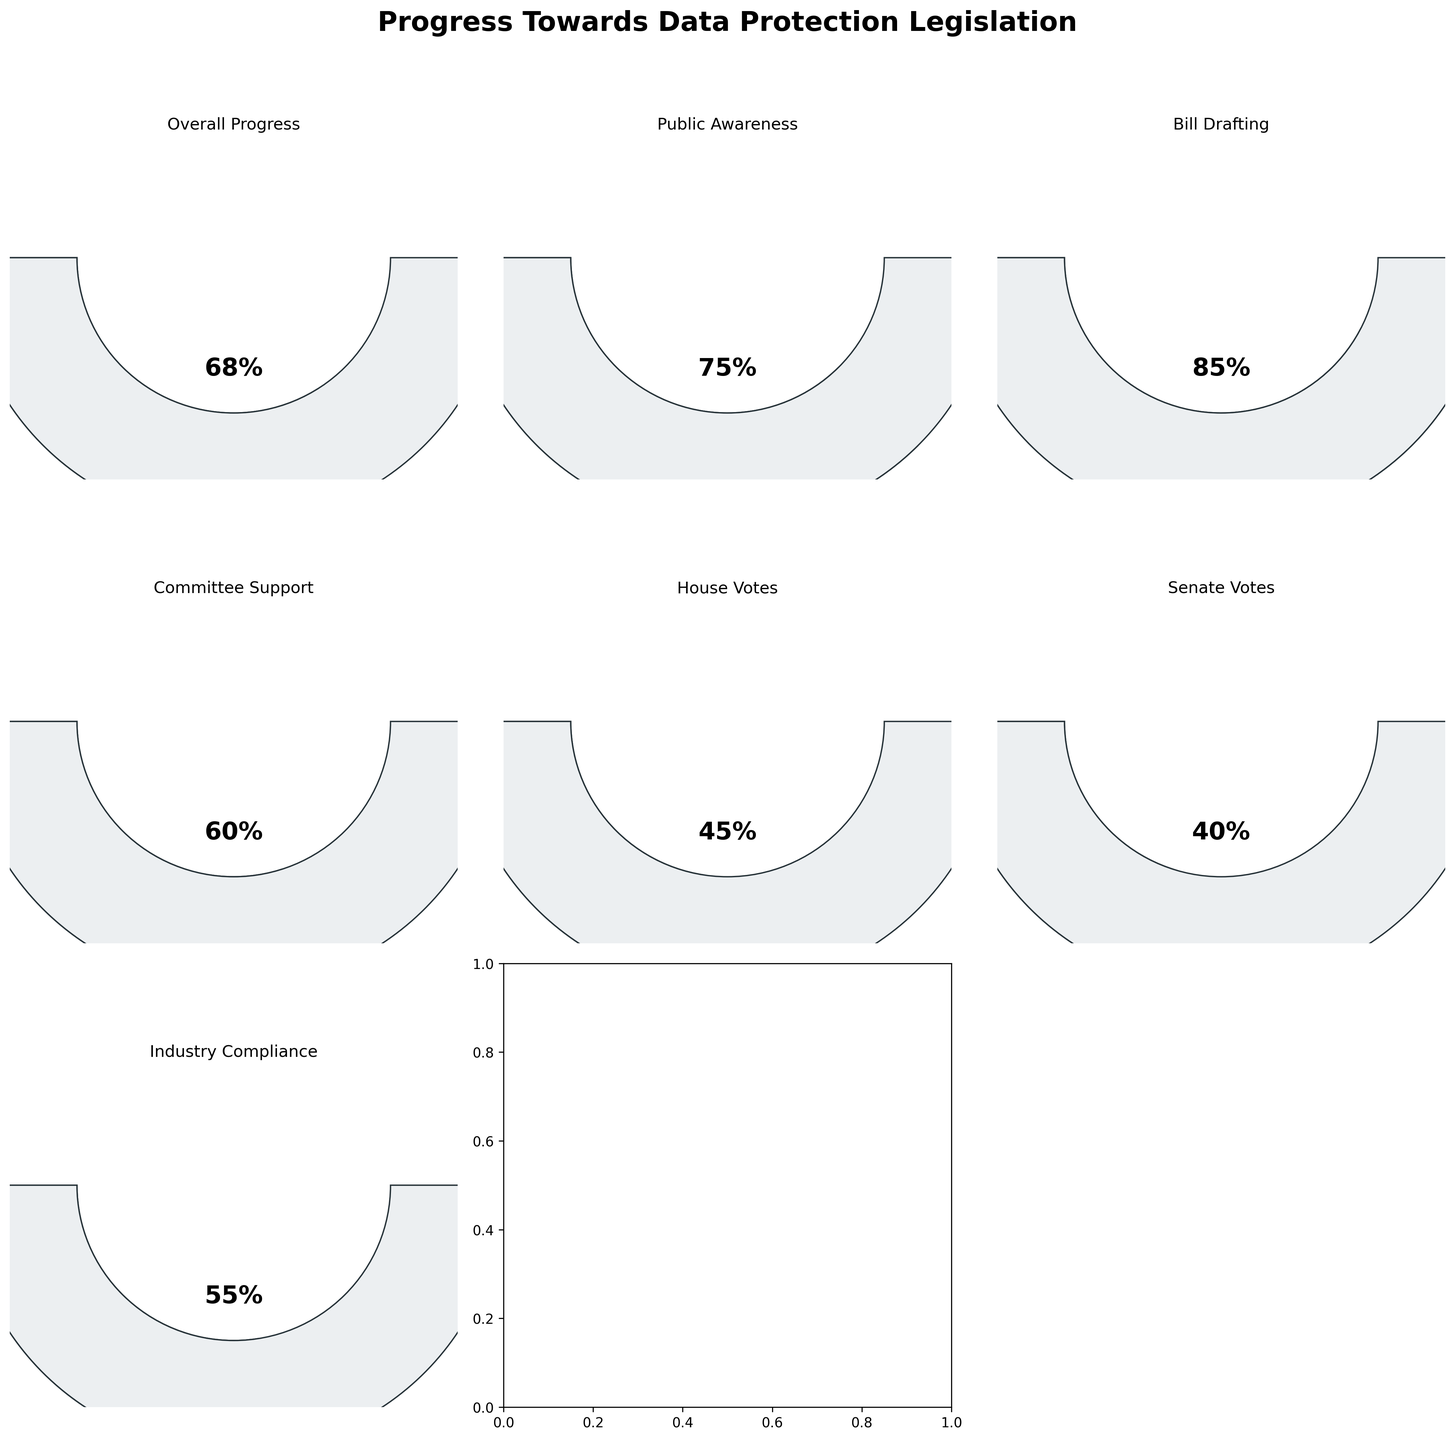What is the overall progress percentage towards the data protection legislation? The overall progress towards the data protection legislation is represented by the "Overall Progress" gauge, which shows 68%.
Answer: 68% Which category has the highest progress percentage? By looking at the different gauges, the "Bill Drafting" category has the highest progress percentage at 85%.
Answer: Bill Drafting How does the progress of public awareness compare to industry compliance? Public awareness has a progress of 75%, whereas industry compliance has a progress of 55%. Therefore, public awareness has made more progress.
Answer: Public awareness has made more progress Which two categories have the lowest progress percentages? The "House Votes" and "Senate Votes" categories have the lowest progress percentages, with 45% and 40% respectively.
Answer: House Votes and Senate Votes What is the average progress percentage across all categories? Add up all the progress percentages (68 + 75 + 85 + 60 + 45 + 40 + 55) to get 428, and then divide by the number of categories (7). The average progress is 428 / 7 ≈ 61.14%.
Answer: 61.14% What is the difference in progress between committee support and senate votes? Committee support has 60% progress, and senate votes have 40% progress. The difference is 60% - 40% = 20%.
Answer: 20% Does any category have exactly half the progress of bill drafting? Bill drafting has 85% progress. Half of 85% is 42.5%. No other category has exactly 42.5%, but the closest is senate votes with 40%.
Answer: No What is the combined progress percentage of committee support and house votes? Both committee support and house votes have 60% and 45% progress respectively. Add 60% and 45% to get a combined progress of 105%.
Answer: 105% How many categories have more than 50% progress? Count the categories with progress greater than 50%. They are: overall progress (68%), public awareness (75%), bill drafting (85%), and committee support (60%). There are four categories in total.
Answer: 4 In terms of progress, how does overall progress relate to the combined value of senate votes and house votes? Overall progress is 68%. Senate votes are 40% and house votes are 45%. Combined, they total 40% + 45% = 85%, which is still higher than the overall progress.
Answer: The combined value is higher 